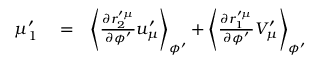<formula> <loc_0><loc_0><loc_500><loc_500>\begin{array} { r l r } { \mu _ { 1 } ^ { \prime } } & = } & { \left \langle \frac { \partial r _ { 2 } ^ { \prime \mu } } { \partial \phi ^ { \prime } } u _ { \mu } ^ { \prime } \right \rangle _ { \phi ^ { \prime } } + \left \langle \frac { \partial r _ { 1 } ^ { \prime \mu } } { \partial \phi ^ { \prime } } V _ { \mu } ^ { \prime } \right \rangle _ { \phi ^ { \prime } } } \end{array}</formula> 